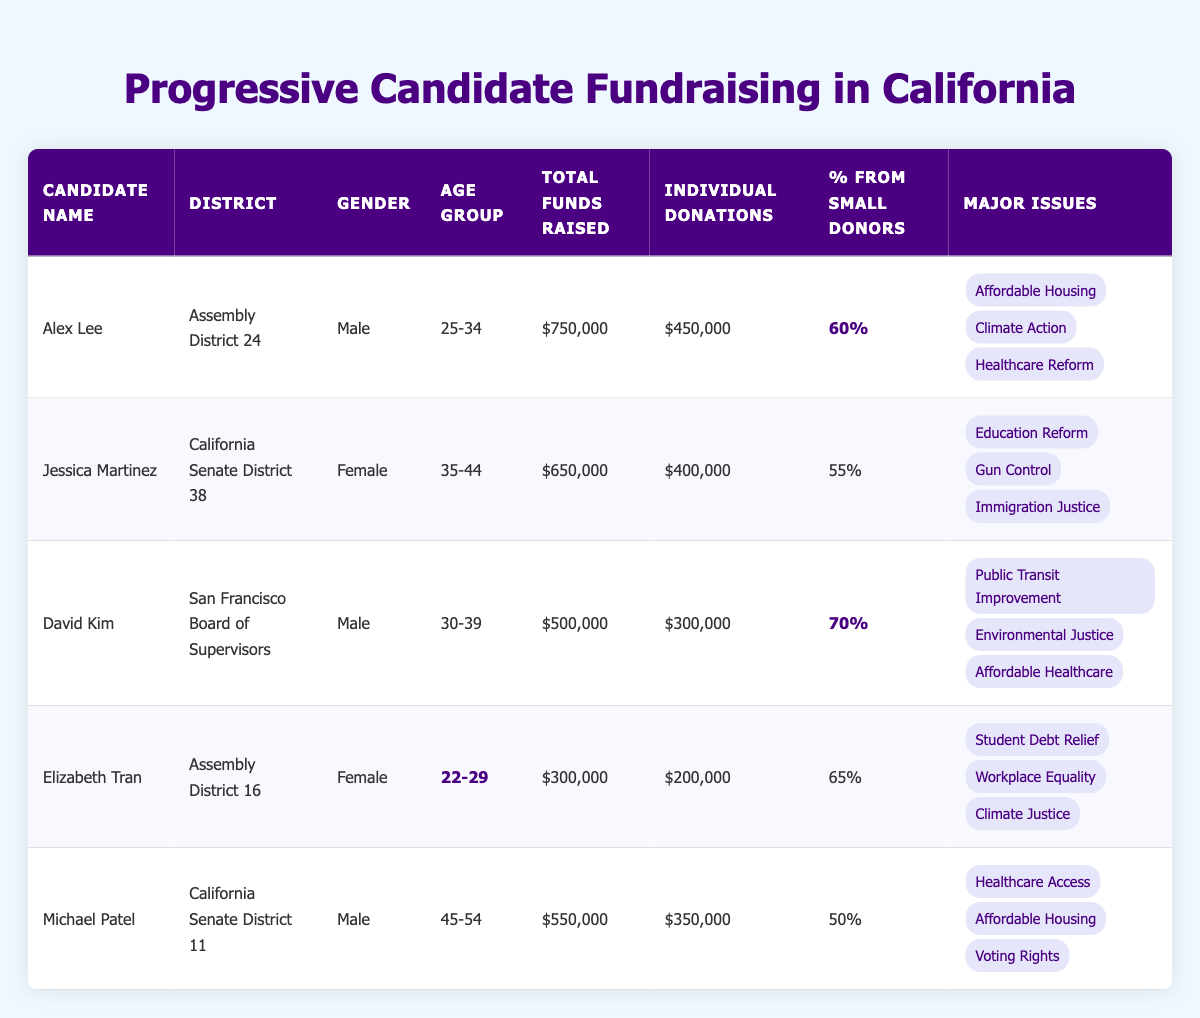What is the total funds raised by Alex Lee? The table shows that Alex Lee raised a total of $750,000.
Answer: $750,000 Which candidate had the highest percentage from small donors? Looking through the percentage column, David Kim has the highest percentage at 70%.
Answer: 70% What is the age group of Elizabeth Tran? The table highlights that Elizabeth Tran is in the age group 22-29.
Answer: 22-29 What are the major issues that Jessica Martinez focuses on? Jessica Martinez's major issues listed in the table are Education Reform, Gun Control, and Immigration Justice.
Answer: Education Reform, Gun Control, Immigration Justice How much total funds were raised by candidates in the age group 35-44? Candidates in that age group are Jessica Martinez, who raised $650,000. The total is $650,000.
Answer: $650,000 Is it true that Michael Patel raised more than Elizabeth Tran? Yes, Michael Patel raised $550,000 and Elizabeth Tran raised $300,000, so it is true.
Answer: Yes What is the average percentage from small donors across all candidates? Adding the percentages from all candidates: (60 + 55 + 70 + 65 + 50) = 300, then dividing by the number of candidates (5) gives an average of 60%.
Answer: 60% Which candidate(s) raised over $500,000 in total funds? The candidates who raised over $500,000 are Alex Lee ($750,000) and Jessica Martinez ($650,000).
Answer: Alex Lee, Jessica Martinez What is the total amount raised by all male candidates? The total for males: Alex Lee ($750,000) + David Kim ($500,000) + Michael Patel ($550,000) = $1,800,000.
Answer: $1,800,000 How many candidates focus on Climate-related issues? The candidates focusing on Climate-related issues are Alex Lee, David Kim, and Elizabeth Tran, totaling three candidates.
Answer: 3 